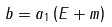<formula> <loc_0><loc_0><loc_500><loc_500>b = a _ { 1 } \left ( E + m \right )</formula> 